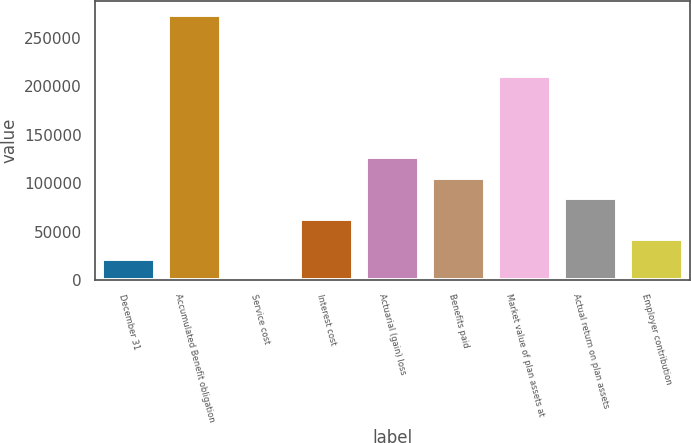Convert chart. <chart><loc_0><loc_0><loc_500><loc_500><bar_chart><fcel>December 31<fcel>Accumulated Benefit obligation<fcel>Service cost<fcel>Interest cost<fcel>Actuarial (gain) loss<fcel>Benefits paid<fcel>Market value of plan assets at<fcel>Actual return on plan assets<fcel>Employer contribution<nl><fcel>21171.5<fcel>274030<fcel>100<fcel>63314.5<fcel>126529<fcel>105458<fcel>210815<fcel>84386<fcel>42243<nl></chart> 